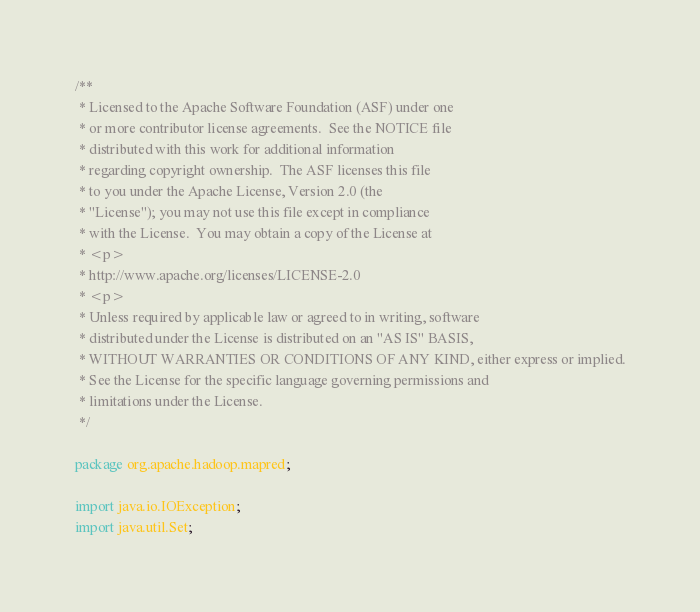<code> <loc_0><loc_0><loc_500><loc_500><_Java_>/**
 * Licensed to the Apache Software Foundation (ASF) under one
 * or more contributor license agreements.  See the NOTICE file
 * distributed with this work for additional information
 * regarding copyright ownership.  The ASF licenses this file
 * to you under the Apache License, Version 2.0 (the
 * "License"); you may not use this file except in compliance
 * with the License.  You may obtain a copy of the License at
 * <p>
 * http://www.apache.org/licenses/LICENSE-2.0
 * <p>
 * Unless required by applicable law or agreed to in writing, software
 * distributed under the License is distributed on an "AS IS" BASIS,
 * WITHOUT WARRANTIES OR CONDITIONS OF ANY KIND, either express or implied.
 * See the License for the specific language governing permissions and
 * limitations under the License.
 */

package org.apache.hadoop.mapred;

import java.io.IOException;
import java.util.Set;</code> 